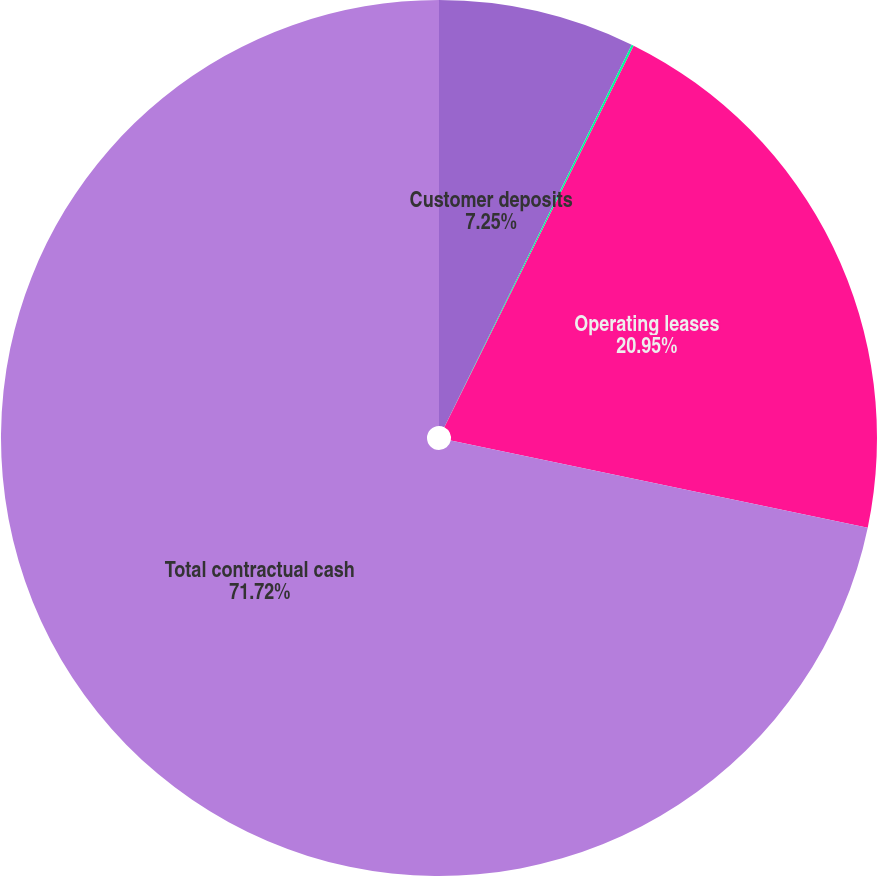Convert chart. <chart><loc_0><loc_0><loc_500><loc_500><pie_chart><fcel>Customer deposits<fcel>Capital lease obligations<fcel>Operating leases<fcel>Total contractual cash<nl><fcel>7.25%<fcel>0.08%<fcel>20.95%<fcel>71.72%<nl></chart> 